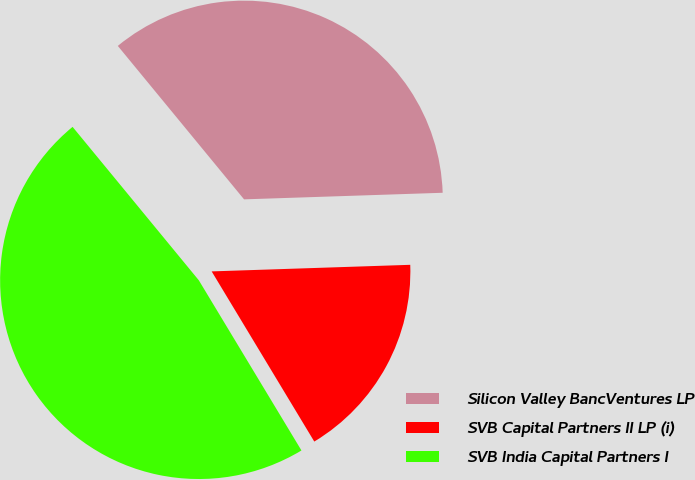Convert chart to OTSL. <chart><loc_0><loc_0><loc_500><loc_500><pie_chart><fcel>Silicon Valley BancVentures LP<fcel>SVB Capital Partners II LP (i)<fcel>SVB India Capital Partners I<nl><fcel>35.43%<fcel>16.89%<fcel>47.68%<nl></chart> 